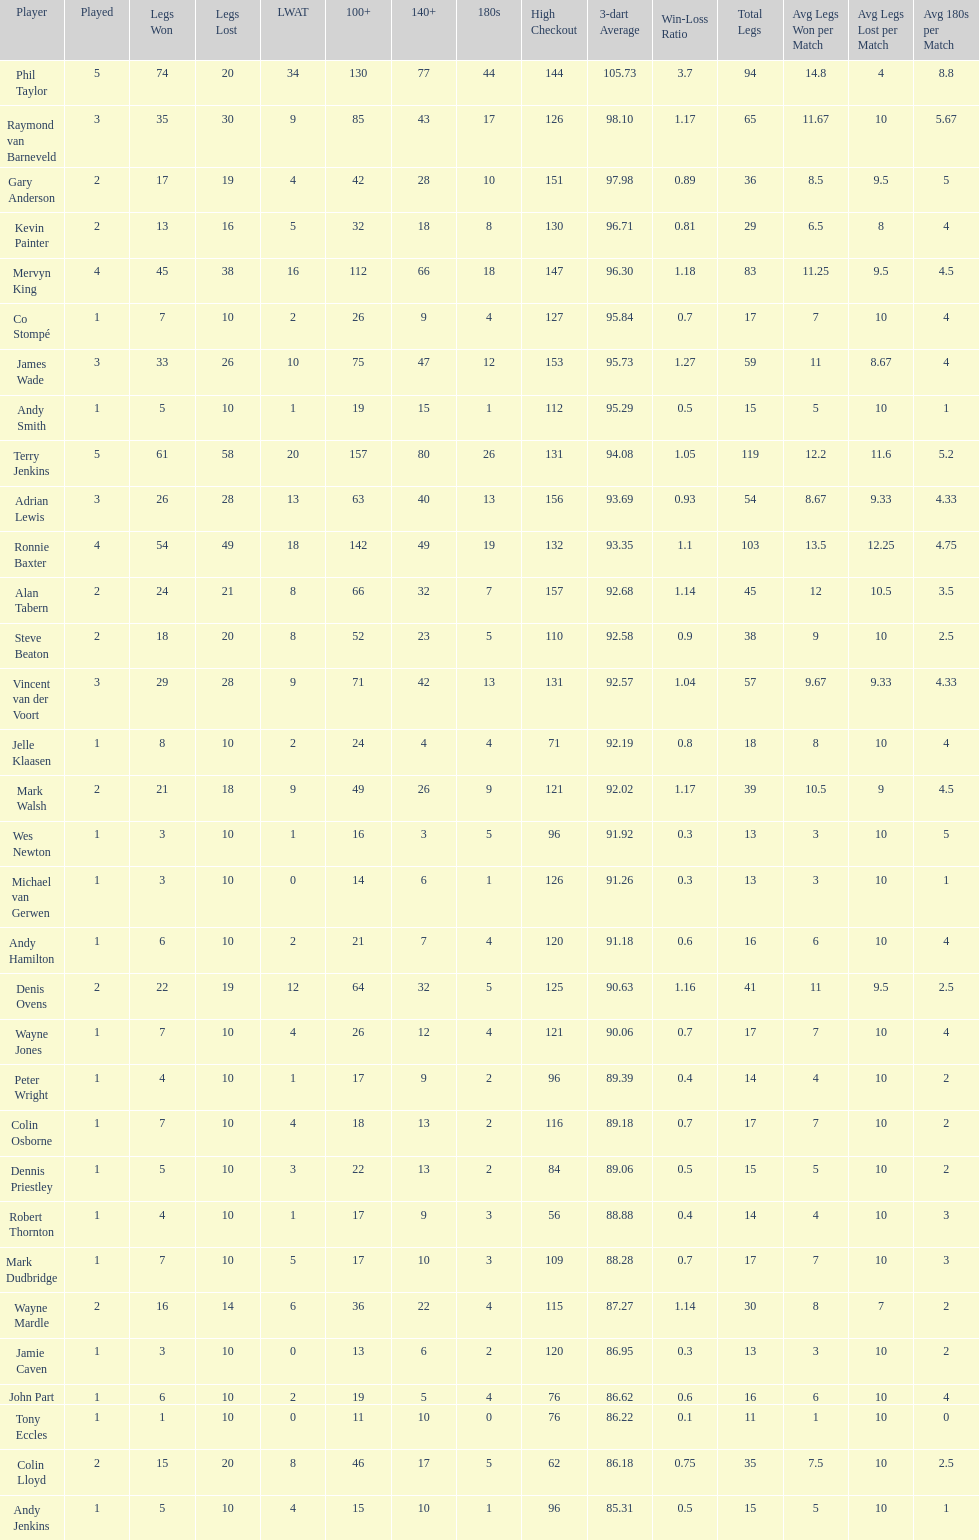Mark walsh's average is above/below 93? Below. 